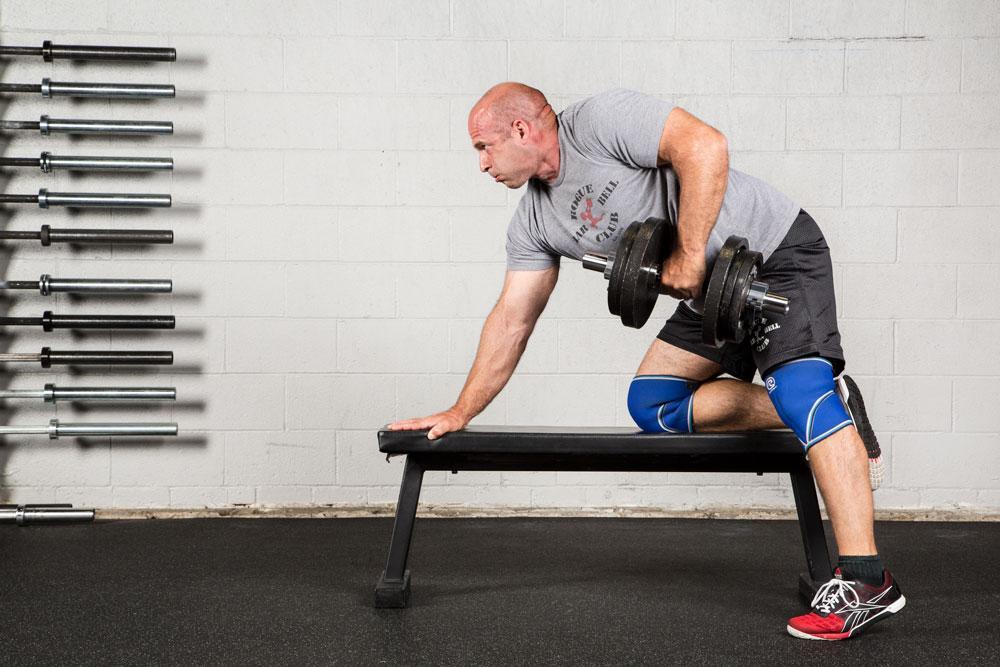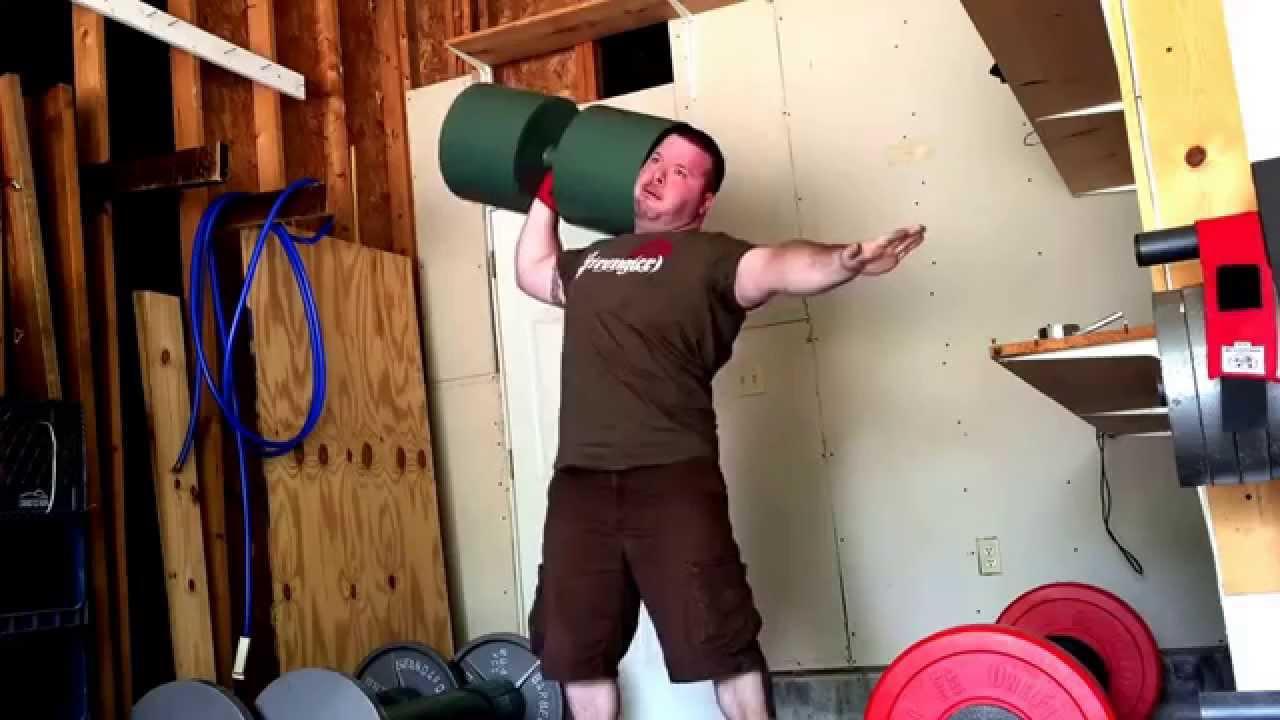The first image is the image on the left, the second image is the image on the right. Assess this claim about the two images: "An image shows a forward-facing man lifting a green barbell with the hand on the left of the image.". Correct or not? Answer yes or no. Yes. 